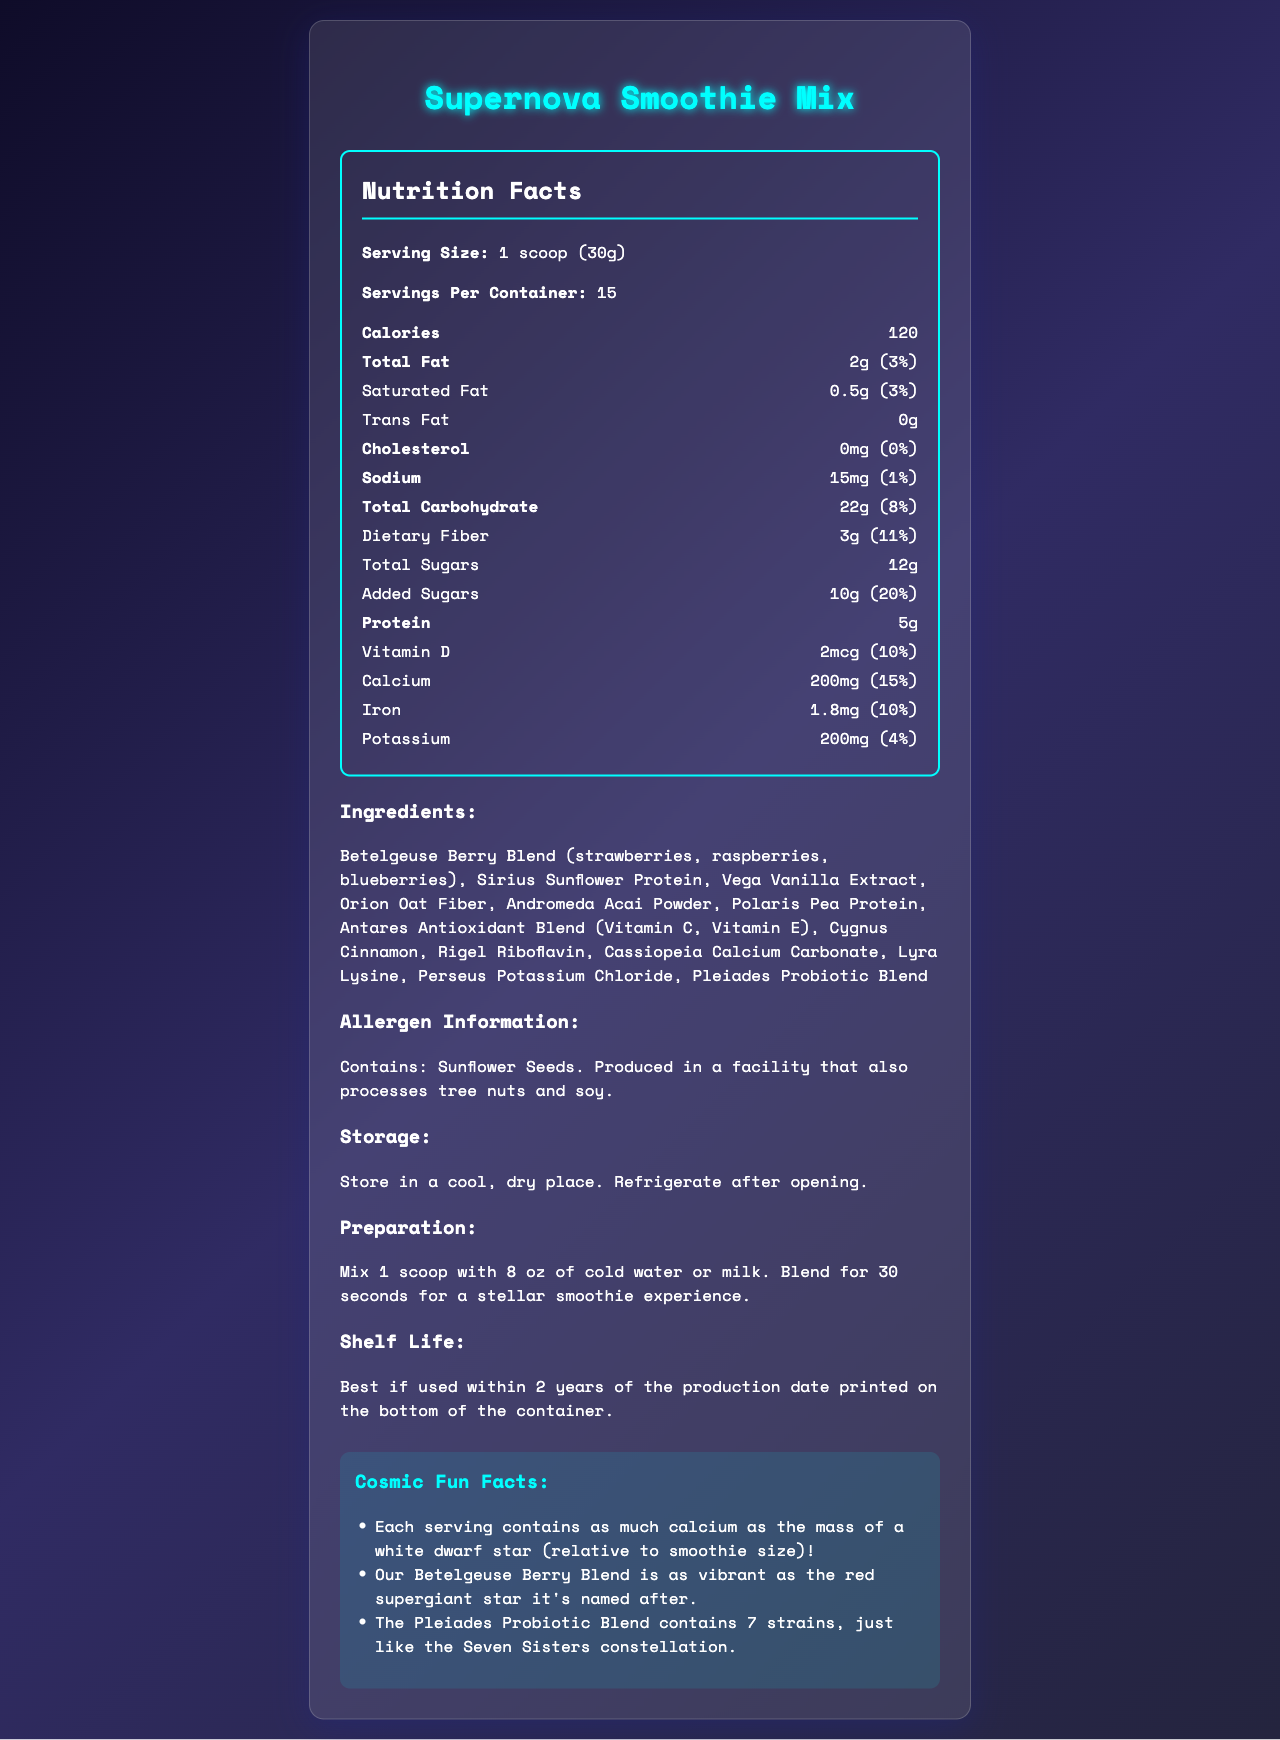what is the serving size? The serving size is explicitly stated in the document under "Serving Size".
Answer: 1 scoop (30g) how many servings are in one container? The document states "Servings Per Container: 15".
Answer: 15 how much protein is in one serving? The document lists the protein content as "Protein: 5g".
Answer: 5g what is the daily value percentage of calcium? The calcium daily value percentage is shown as "Calcium: 200mg (15%)".
Answer: 15% what is the amount of added sugars? The "Added Sugars" section specifies the amount as "10g".
Answer: 10g which ingredient contains a blend of Vitamin C and Vitamin E? A. Andromeda Acai Powder B. Antares Antioxidant Blend C. Vega Vanilla Extract D. Rigel Riboflavin Antares Antioxidant Blend consists of Vitamin C and Vitamin E as indicated in the ingredients list.
Answer: B what is the daily value percentage of dietary fiber? A. 8% B. 11% C. 15% D. 20% The daily value percentage for dietary fiber is shown to be "11%".
Answer: B does the product contain trans fat? The document states "Trans Fat: 0g".
Answer: No is this product safe for people who are allergic to tree nuts? The allergen information indicates that the product is produced in a facility that also processes tree nuts.
Answer: No summarize the main idea of the document. The document is a comprehensive overview of the "Supernova Smoothie Mix," detailing its nutritional profile, ingredient list, and special characteristics named after astronomical entities, along with storage and preparation guidelines.
Answer: The document presents the nutrition facts, ingredients, allergen information, storage instructions, preparation instructions, shelf life, and fun facts about "Supernova Smoothie Mix." It highlights serving size, calories, nutritional content, and a blend of ingredients named after famous stars and constellations. who manufactured the Supernova Smoothie Mix? The document does not provide any information about the manufacturer.
Answer: Not enough information how many grams of total carbohydrates are there per serving? The total carbohydrate content is listed as "Total Carbohydrate: 22g".
Answer: 22g 